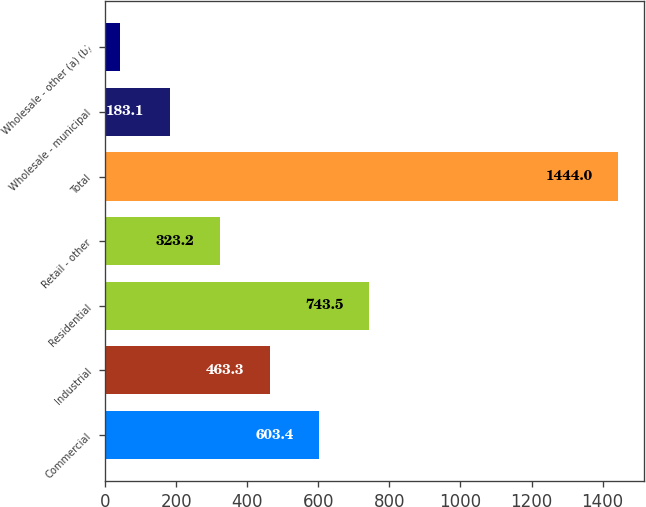Convert chart. <chart><loc_0><loc_0><loc_500><loc_500><bar_chart><fcel>Commercial<fcel>Industrial<fcel>Residential<fcel>Retail - other<fcel>Total<fcel>Wholesale - municipal<fcel>Wholesale - other (a) (b)<nl><fcel>603.4<fcel>463.3<fcel>743.5<fcel>323.2<fcel>1444<fcel>183.1<fcel>43<nl></chart> 